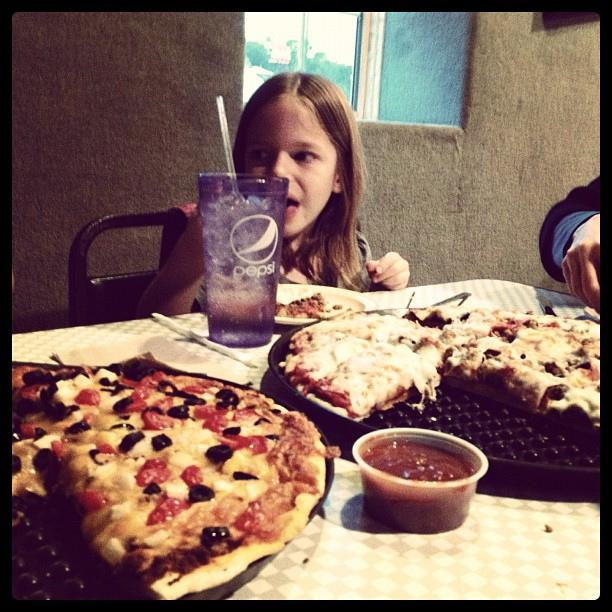What sort of sauce is found in the plastic cup?

Choices:
A) cheese
B) salsa
C) marinara
D) taco marinara 